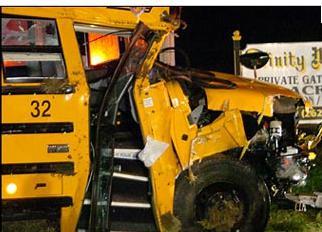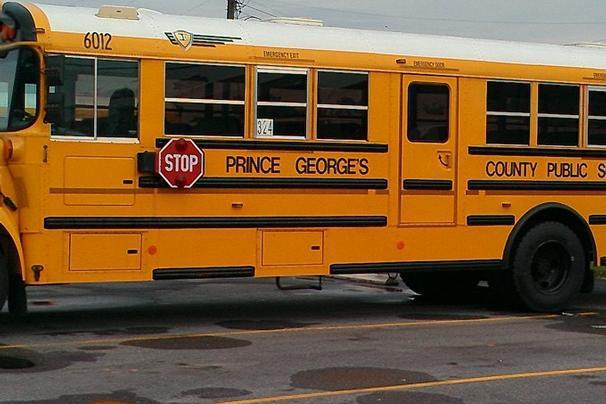The first image is the image on the left, the second image is the image on the right. Given the left and right images, does the statement "There is no apparent damage to the bus in the image on the right." hold true? Answer yes or no. Yes. 